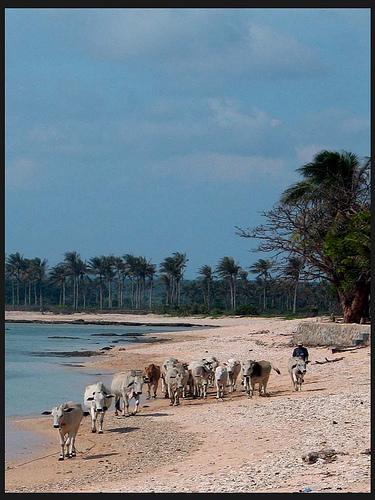Is this a zoo?
Concise answer only. No. How many surfaces can be seen?
Write a very short answer. 2. Are the trees growing in the same direction?
Write a very short answer. Yes. What type of trees are in the background?
Quick response, please. Palm. Is the picture in black and white?
Write a very short answer. No. What natural structure is behind the trees?
Write a very short answer. Mountain. How many sheep are in this picture?
Quick response, please. 0. Where are these animals?
Keep it brief. Cows. Is this the zoo?
Keep it brief. No. Is there a greenhouse in this picture?
Concise answer only. No. What is on the right foreground of the image?
Write a very short answer. Sand. 